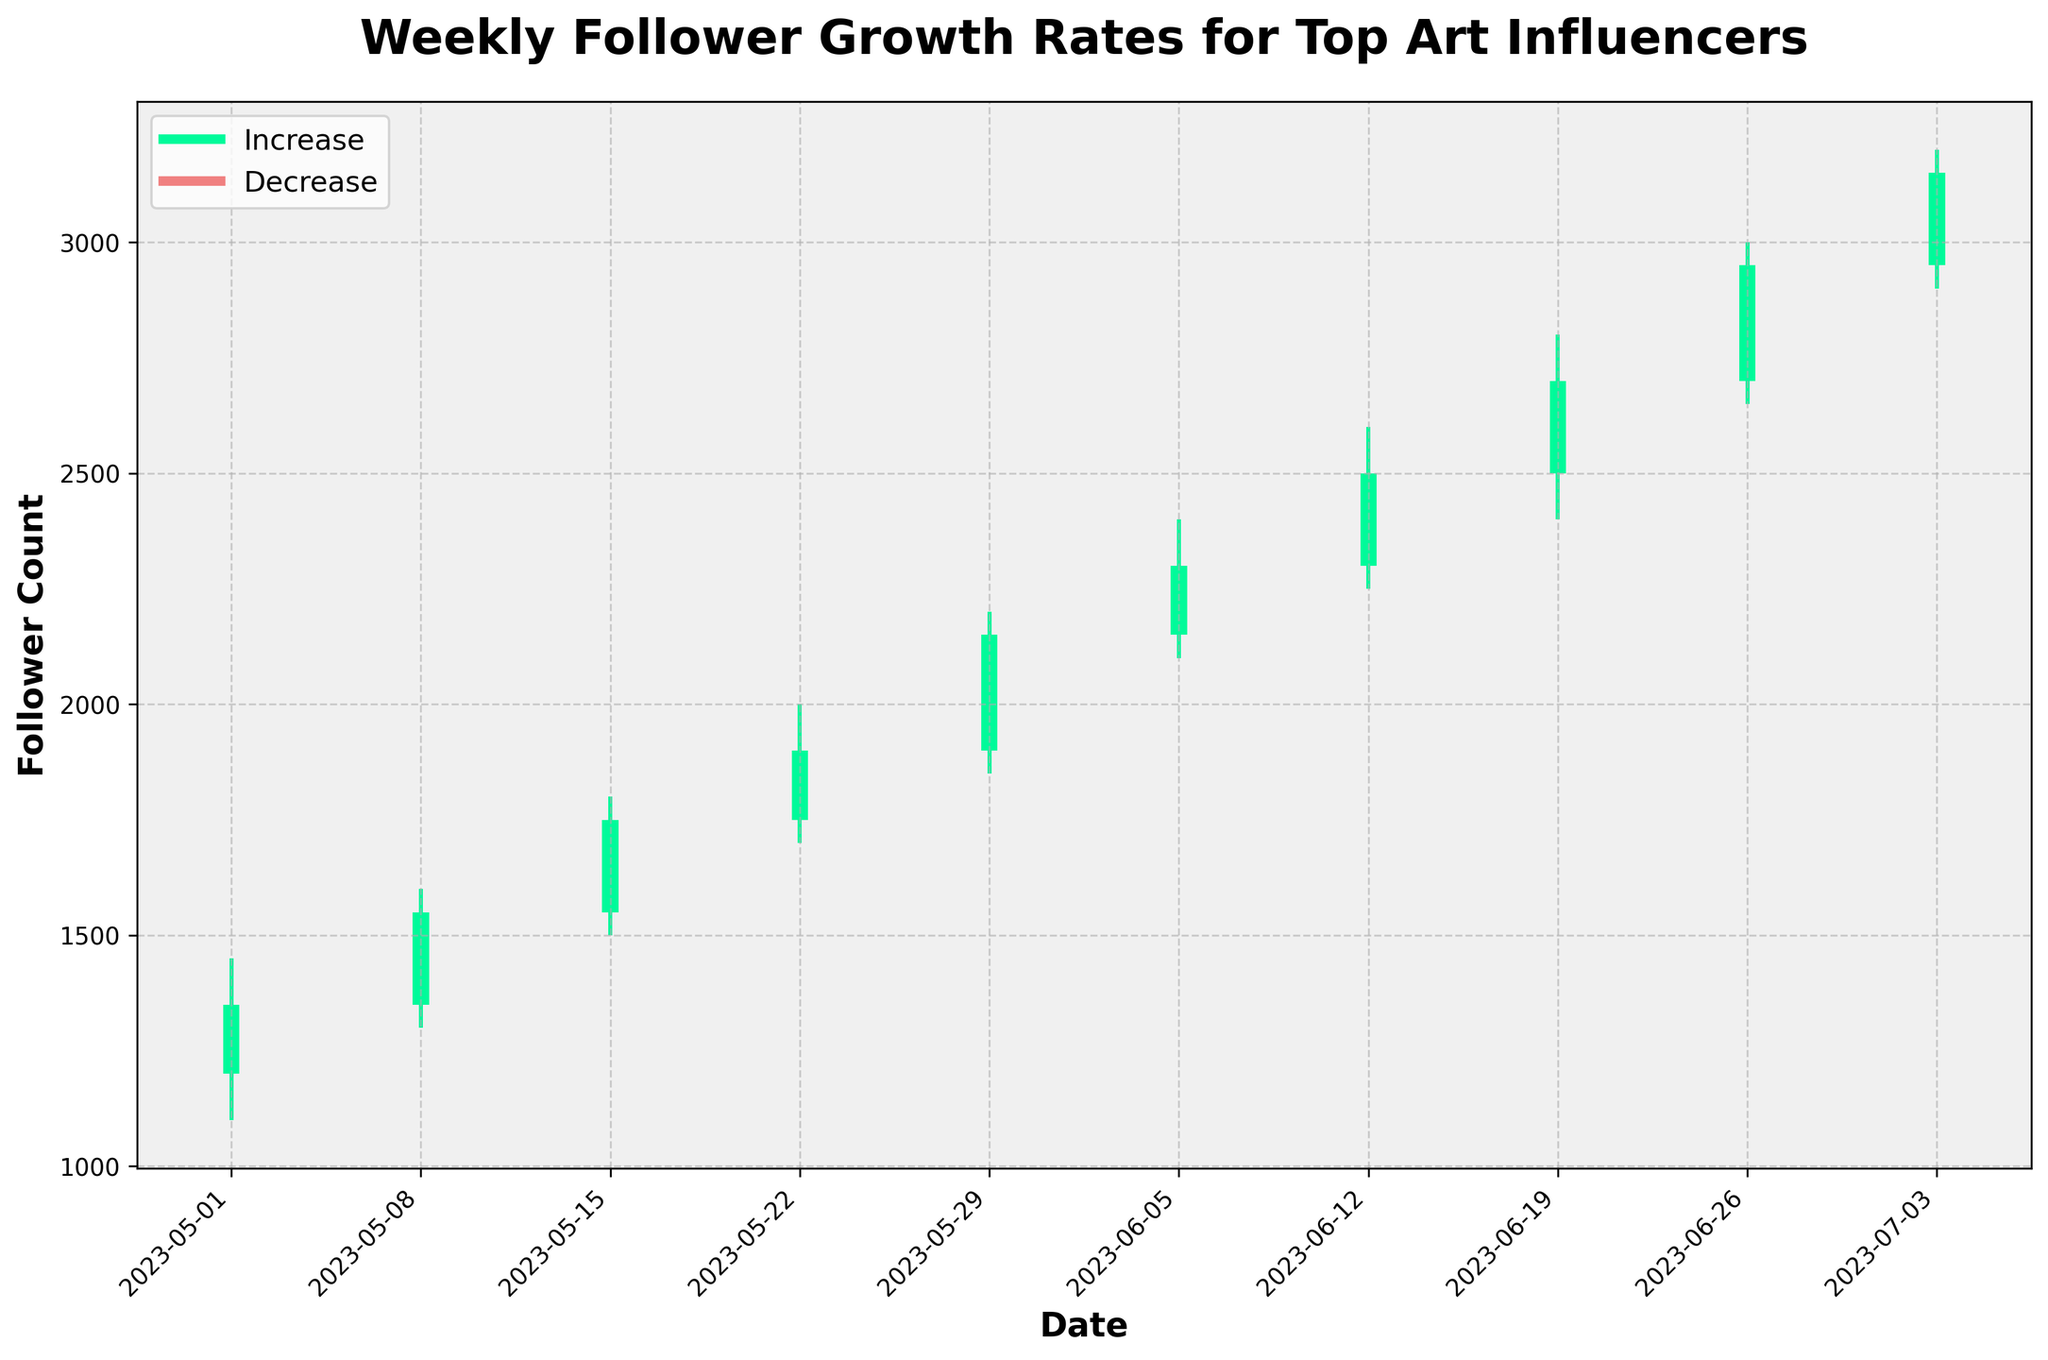what is the title of the plot? The title is displayed at the top of the plot and reads: "Weekly Follower Growth Rates for Top Art Influencers."
Answer: Weekly Follower Growth Rates for Top Art Influencers what are the colors used to represent an increase or decrease in followers? The color representing an increase in followers is medium spring green, and the color representing a decrease is light coral.
Answer: medium spring green and light coral how many weeks show an increase in followers? By observing the color-coded bars in the plot, the weeks that show an increase are depicted in medium spring green, and there are 10 such weeks.
Answer: 10 what was the highest follower count and on which date did it occur? The highest follower count is indicated by the upper limit of the tallest bar, which is 3200, and it occurs on July 3, 2023.
Answer: 3200 on July 3, 2023 which week had the smallest range between the highest and lowest follower counts? The range is calculated by subtracting the low value from the high value for each week. The smallest range is for the week starting May 29 (2200-1850=350).
Answer: Week starting May 29 which two consecutive weeks had the smallest overall increase in followers? Calculate the difference between the closing follower count of one week and the opening follower count of the next week. The smallest increase between two consecutive weeks is between May 15 and May 29 (1550-1350=200).
Answer: May 15 and May 29 compare the follower count on the weeks starting June 19 and June 26. which one saw a larger increase? Compare the difference between the open and close values: June 19 (2700-2500=200) and June 26 (2950-2700=250). The week starting June 26 saw a larger increase.
Answer: Week starting June 26 what was the follower count difference between the opening of May 1 and the closing of July 3? Calculate the difference between the follower count of May 1 (Open=1200) and July 3 (Close=3150), which results in an increase of 1950.
Answer: 1950 what was the average increase in followers per week? Add the weekly increases: (1350-1200), (1550-1350), (1750-1550), (1900-1750), (2150-1900), (2300-2150), (2500-2300), (2700-2500), (2950-2700), (3150-2950). Sum these values and divide by 10. The average increase is 200.
Answer: 200 